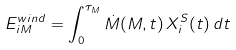<formula> <loc_0><loc_0><loc_500><loc_500>E _ { i M } ^ { w i n d } = \int _ { 0 } ^ { \tau _ { M } } \dot { M } ( M , t ) \, X _ { i } ^ { S } ( t ) \, d t</formula> 